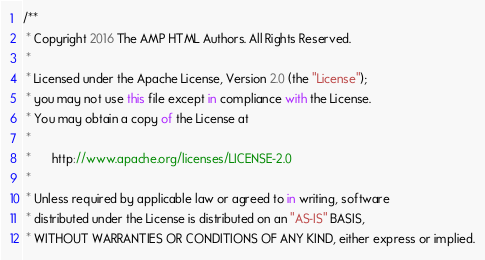<code> <loc_0><loc_0><loc_500><loc_500><_JavaScript_>/**
 * Copyright 2016 The AMP HTML Authors. All Rights Reserved.
 *
 * Licensed under the Apache License, Version 2.0 (the "License");
 * you may not use this file except in compliance with the License.
 * You may obtain a copy of the License at
 *
 *      http://www.apache.org/licenses/LICENSE-2.0
 *
 * Unless required by applicable law or agreed to in writing, software
 * distributed under the License is distributed on an "AS-IS" BASIS,
 * WITHOUT WARRANTIES OR CONDITIONS OF ANY KIND, either express or implied.</code> 